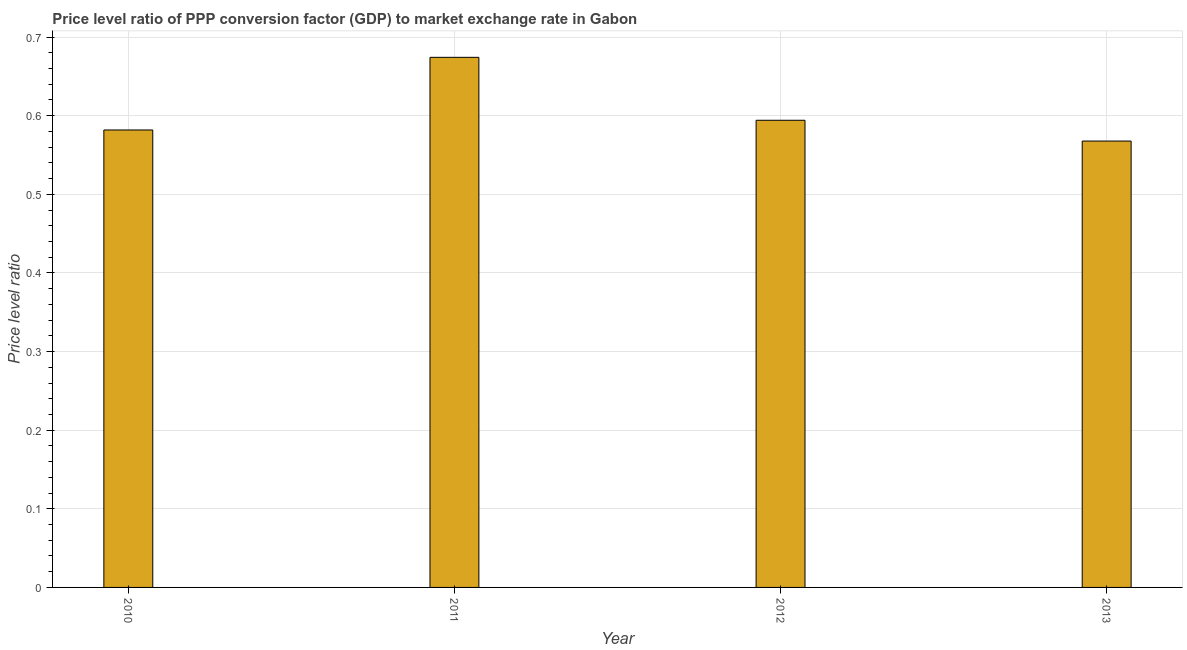Does the graph contain any zero values?
Keep it short and to the point. No. Does the graph contain grids?
Your answer should be very brief. Yes. What is the title of the graph?
Give a very brief answer. Price level ratio of PPP conversion factor (GDP) to market exchange rate in Gabon. What is the label or title of the Y-axis?
Provide a succinct answer. Price level ratio. What is the price level ratio in 2013?
Your response must be concise. 0.57. Across all years, what is the maximum price level ratio?
Keep it short and to the point. 0.67. Across all years, what is the minimum price level ratio?
Your answer should be compact. 0.57. What is the sum of the price level ratio?
Offer a very short reply. 2.42. What is the difference between the price level ratio in 2012 and 2013?
Your response must be concise. 0.03. What is the average price level ratio per year?
Your response must be concise. 0.6. What is the median price level ratio?
Your answer should be compact. 0.59. What is the ratio of the price level ratio in 2010 to that in 2012?
Ensure brevity in your answer.  0.98. Is the difference between the price level ratio in 2011 and 2013 greater than the difference between any two years?
Your response must be concise. Yes. What is the difference between the highest and the second highest price level ratio?
Your answer should be compact. 0.08. Is the sum of the price level ratio in 2012 and 2013 greater than the maximum price level ratio across all years?
Provide a succinct answer. Yes. What is the difference between the highest and the lowest price level ratio?
Give a very brief answer. 0.11. How many bars are there?
Provide a succinct answer. 4. Are all the bars in the graph horizontal?
Your answer should be compact. No. What is the difference between two consecutive major ticks on the Y-axis?
Keep it short and to the point. 0.1. Are the values on the major ticks of Y-axis written in scientific E-notation?
Offer a very short reply. No. What is the Price level ratio in 2010?
Your answer should be very brief. 0.58. What is the Price level ratio in 2011?
Give a very brief answer. 0.67. What is the Price level ratio of 2012?
Provide a succinct answer. 0.59. What is the Price level ratio in 2013?
Make the answer very short. 0.57. What is the difference between the Price level ratio in 2010 and 2011?
Your answer should be compact. -0.09. What is the difference between the Price level ratio in 2010 and 2012?
Ensure brevity in your answer.  -0.01. What is the difference between the Price level ratio in 2010 and 2013?
Offer a terse response. 0.01. What is the difference between the Price level ratio in 2011 and 2012?
Make the answer very short. 0.08. What is the difference between the Price level ratio in 2011 and 2013?
Give a very brief answer. 0.11. What is the difference between the Price level ratio in 2012 and 2013?
Your response must be concise. 0.03. What is the ratio of the Price level ratio in 2010 to that in 2011?
Ensure brevity in your answer.  0.86. What is the ratio of the Price level ratio in 2011 to that in 2012?
Give a very brief answer. 1.14. What is the ratio of the Price level ratio in 2011 to that in 2013?
Provide a succinct answer. 1.19. What is the ratio of the Price level ratio in 2012 to that in 2013?
Keep it short and to the point. 1.05. 